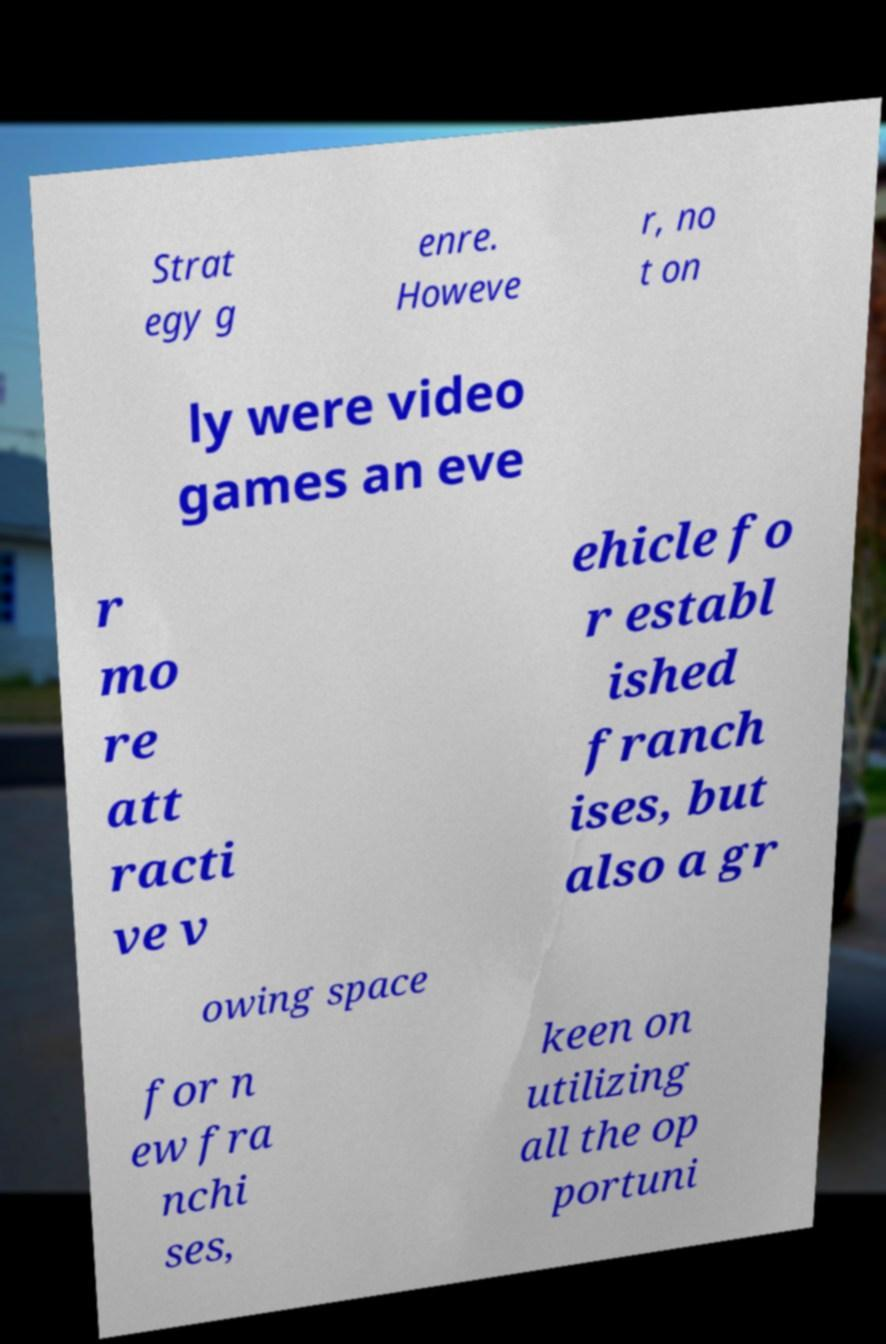For documentation purposes, I need the text within this image transcribed. Could you provide that? Strat egy g enre. Howeve r, no t on ly were video games an eve r mo re att racti ve v ehicle fo r establ ished franch ises, but also a gr owing space for n ew fra nchi ses, keen on utilizing all the op portuni 